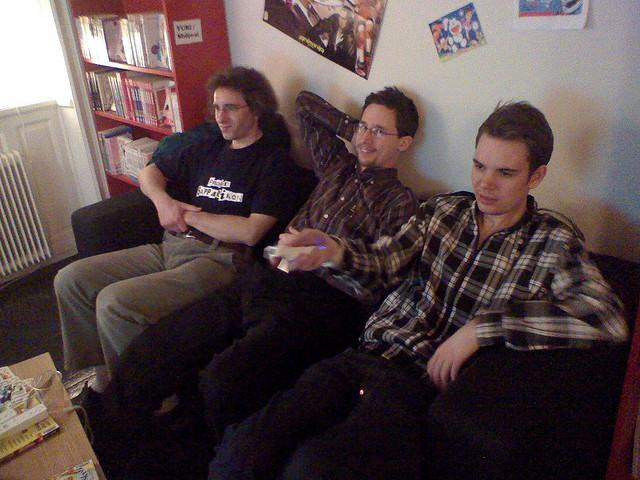What are these people engaging in?

Choices:
A) singing karaoke
B) watching movie
C) reading books
D) video game video game 